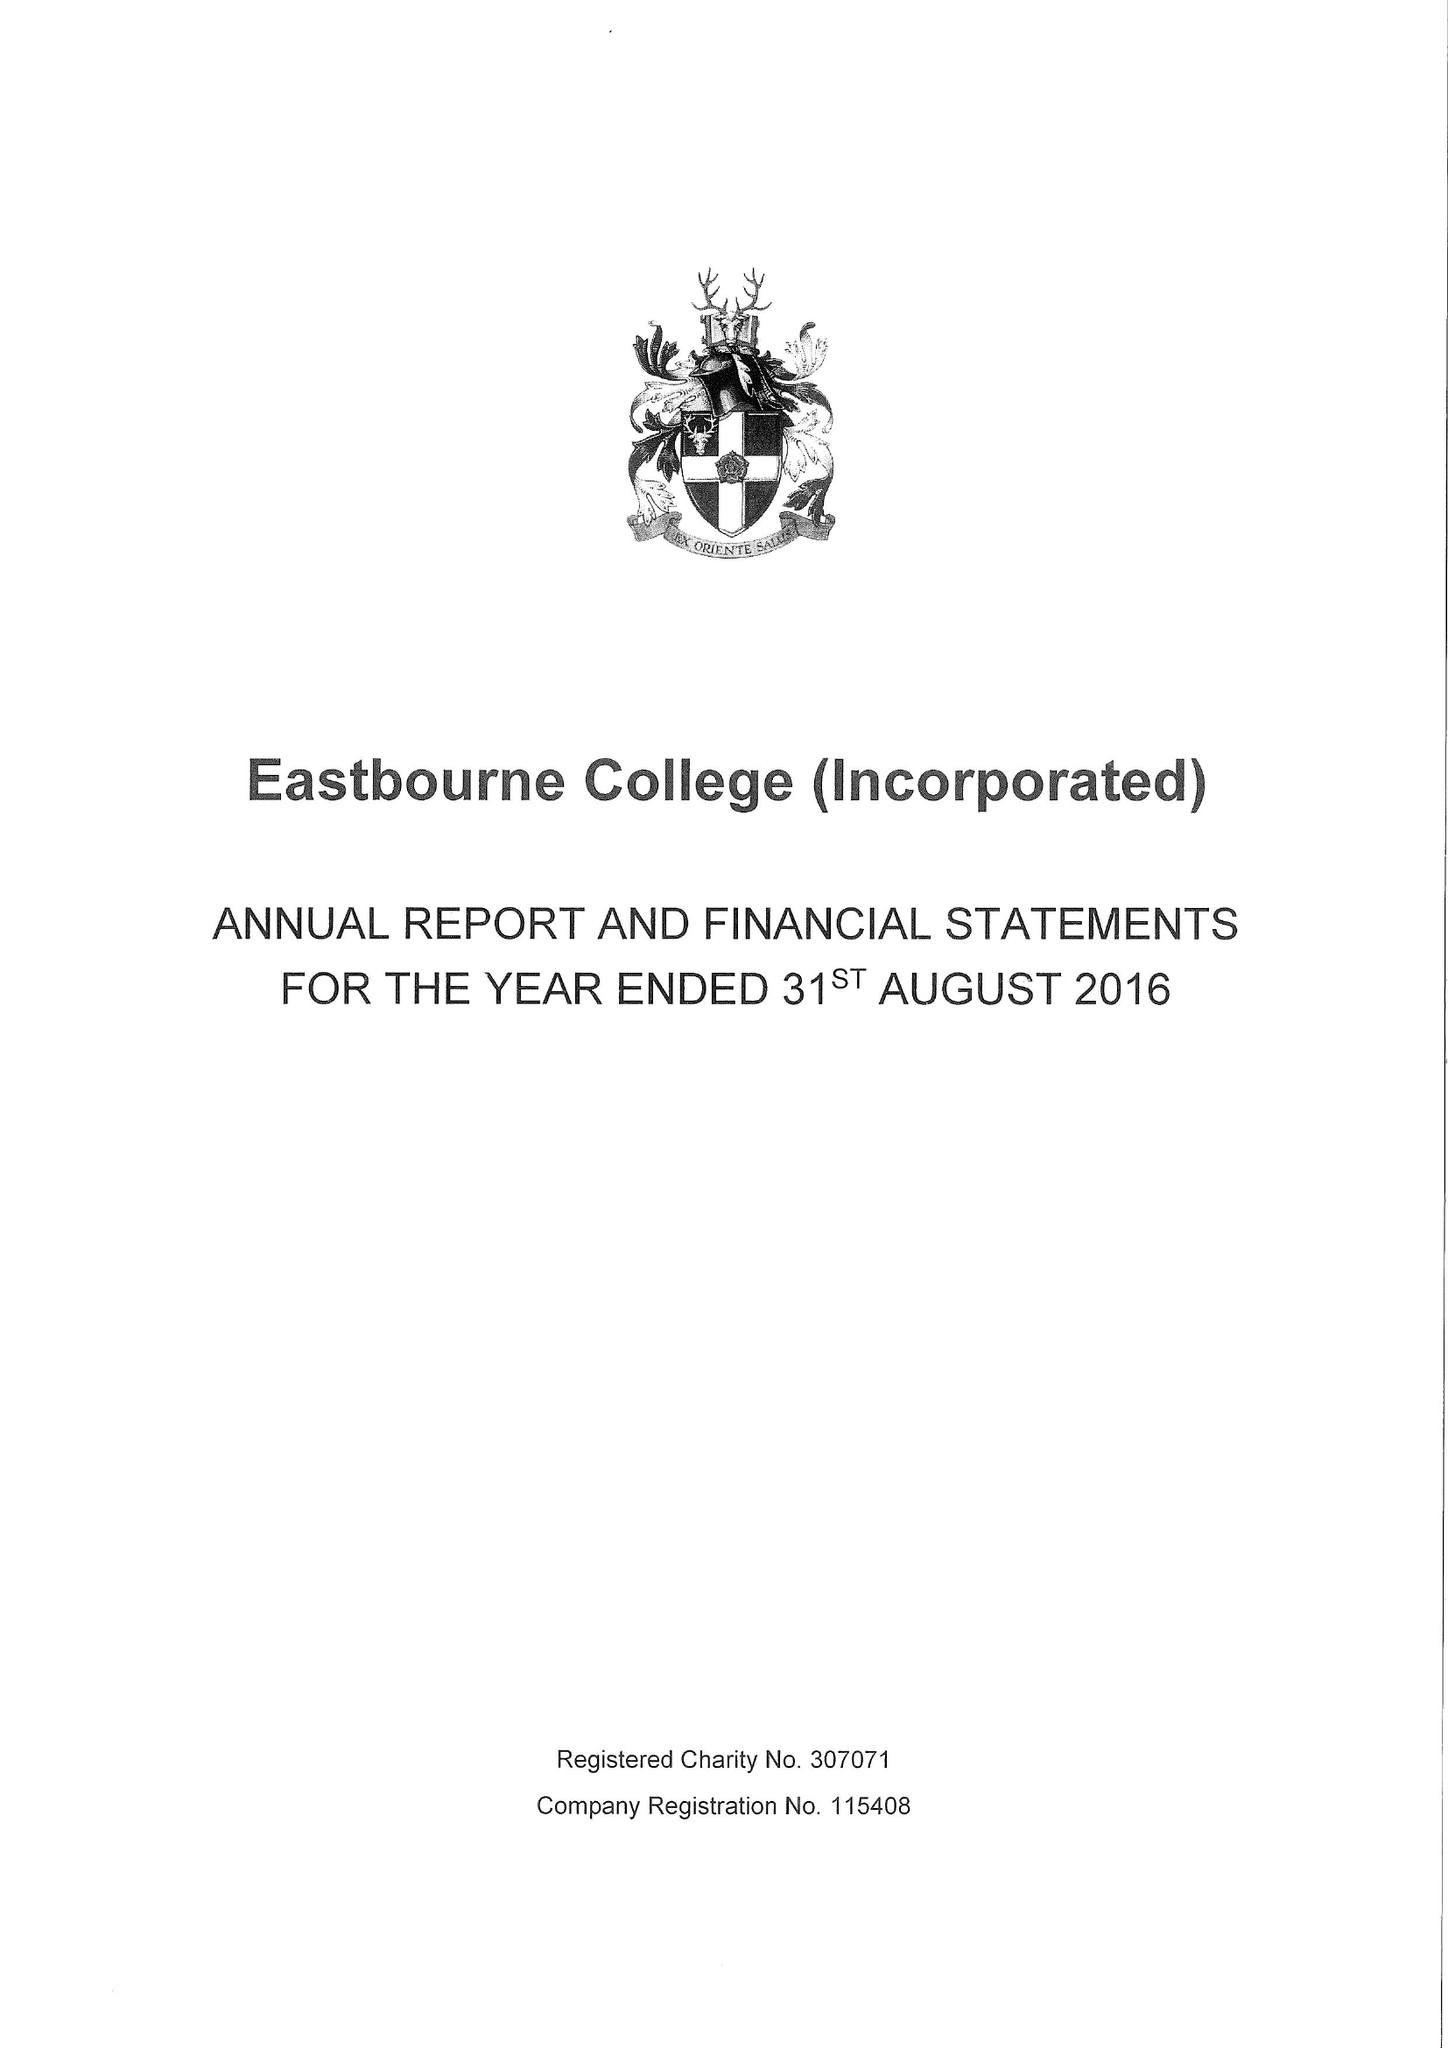What is the value for the report_date?
Answer the question using a single word or phrase. 2016-08-31 